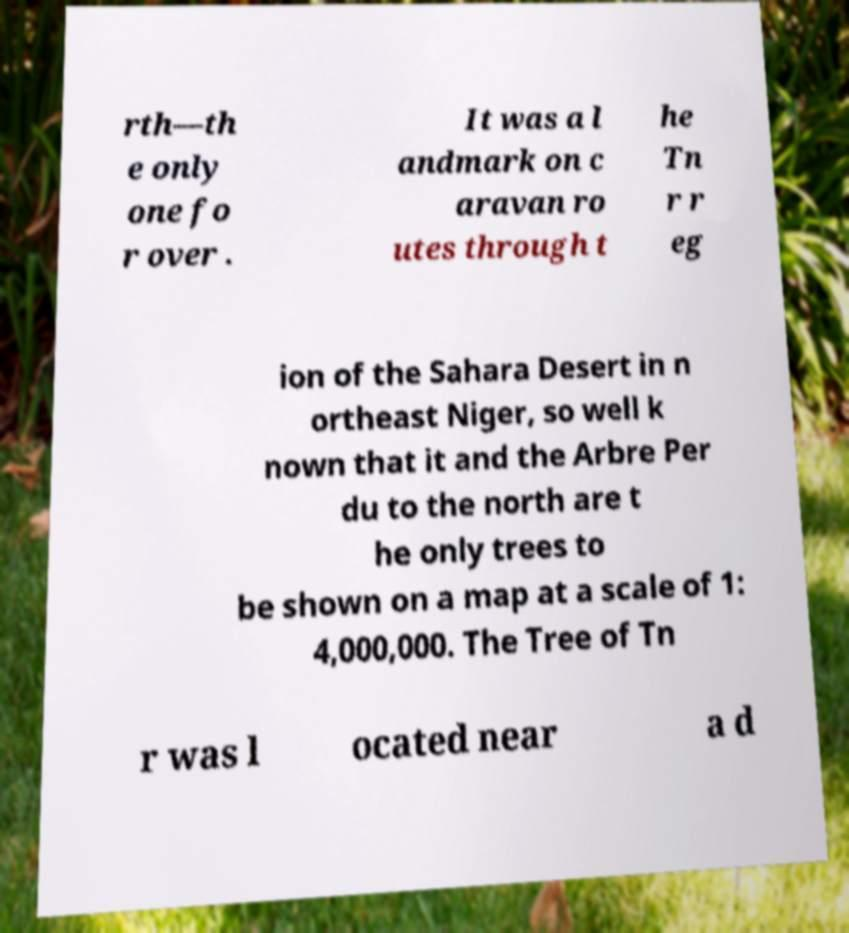Could you assist in decoding the text presented in this image and type it out clearly? rth—th e only one fo r over . It was a l andmark on c aravan ro utes through t he Tn r r eg ion of the Sahara Desert in n ortheast Niger, so well k nown that it and the Arbre Per du to the north are t he only trees to be shown on a map at a scale of 1: 4,000,000. The Tree of Tn r was l ocated near a d 